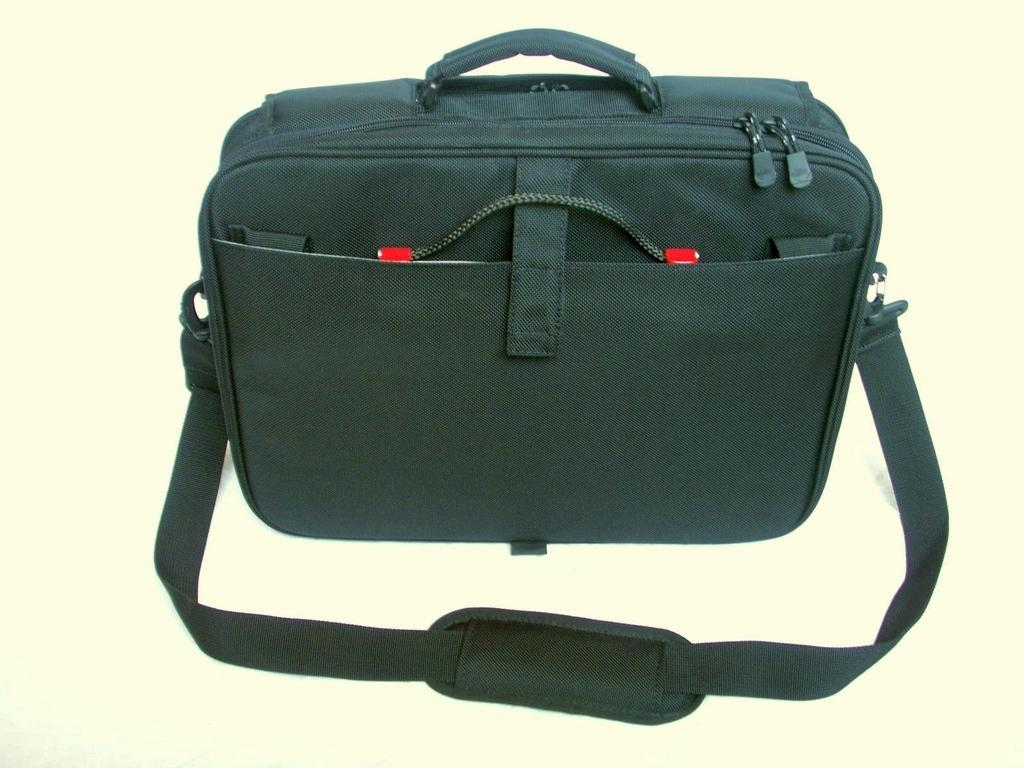What type of bag is visible in the image? There is a black bag in the image. What type of feast is being prepared in the image? There is no feast or any indication of food preparation in the image; it only shows a black bag. 